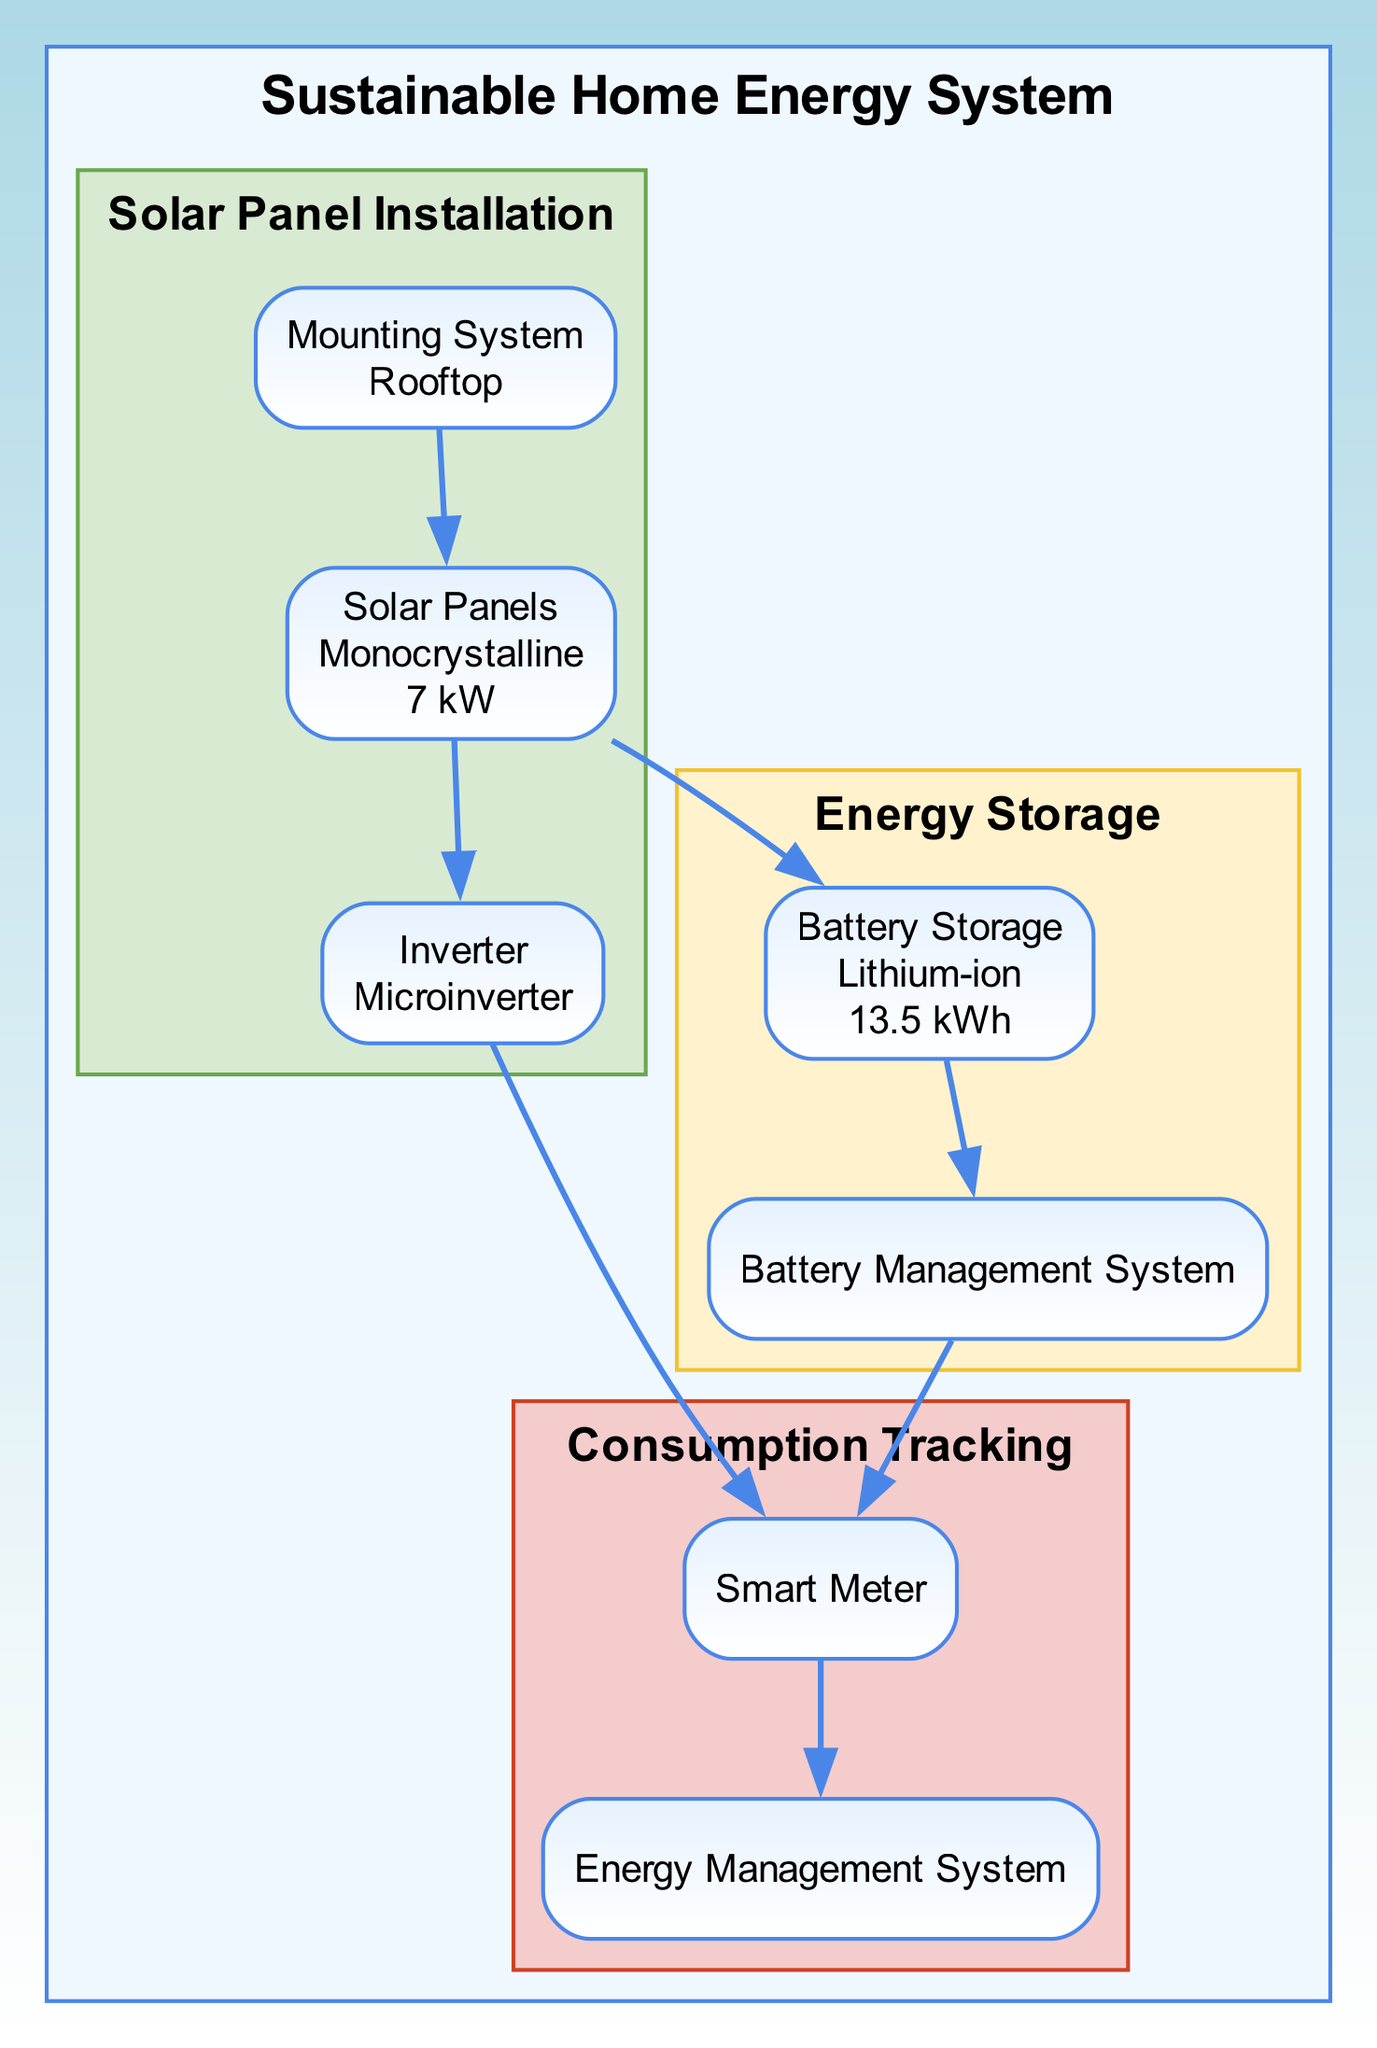What type of solar panels are used in this system? The diagram shows that the solar panels installed are of the type "Monocrystalline". This information can be found directly under the Solar Panels node in the Solar Panel Installation section.
Answer: Monocrystalline How many units of battery storage are present? The diagrams specify that there are 2 units of battery storage in the Energy Storage section under the Battery Storage node.
Answer: 2 What is the capacity of the battery storage? The capacity listed under the Battery Storage node is "13.5 kWh", which directly answers this question without requiring additional calculations or inferences.
Answer: 13.5 kWh What brand of inverter is used in the installation? The inverter node specifies that the brand used is "Enphase". This information is clear and directly stated in the diagram.
Answer: Enphase How does solar energy flow from the solar panels to energy storage? The diagram shows an edge connecting the Solar Panels to the Battery Storage. This indicates a direct flow or transfer of solar energy from the solar panels for storage in battery units, confirming the relationship.
Answer: Solar energy flows via the edge connecting Solar Panels to Battery Storage What features does the Battery Management System offer? The Battery Management System node lists three features: "Efficiency optimization", "Real-time monitoring", and "Thermal management". Each of these features contributes to managing battery performance, which can be answered by checking the associated features listed under the node.
Answer: Efficiency optimization, Real-time monitoring, Thermal management Which devices are integrated into the Energy Management System? The diagram shows two integrations listed: "Mobile App" and "Home Automation". Under the Mobile App node are the platforms iOS and Android, while the Home Automation node includes Google Home and Amazon Alexa. These integrations enhance energy tracking and management systems.
Answer: Mobile App (iOS, Android), Home Automation (Google Home, Amazon Alexa) Which component tracks carbon footprint in the system? According to the diagram, the Smart Meter has a feature called "Carbon footprint tracking", indicating its ability to monitor and record the carbon footprint as part of the overall system performance and consumption.
Answer: Smart Meter What type of battery storage is used? The Battery Storage node specifies that the type of battery storage is "Lithium-ion". This type is noted directly in the relevant section of the diagram.
Answer: Lithium-ion 